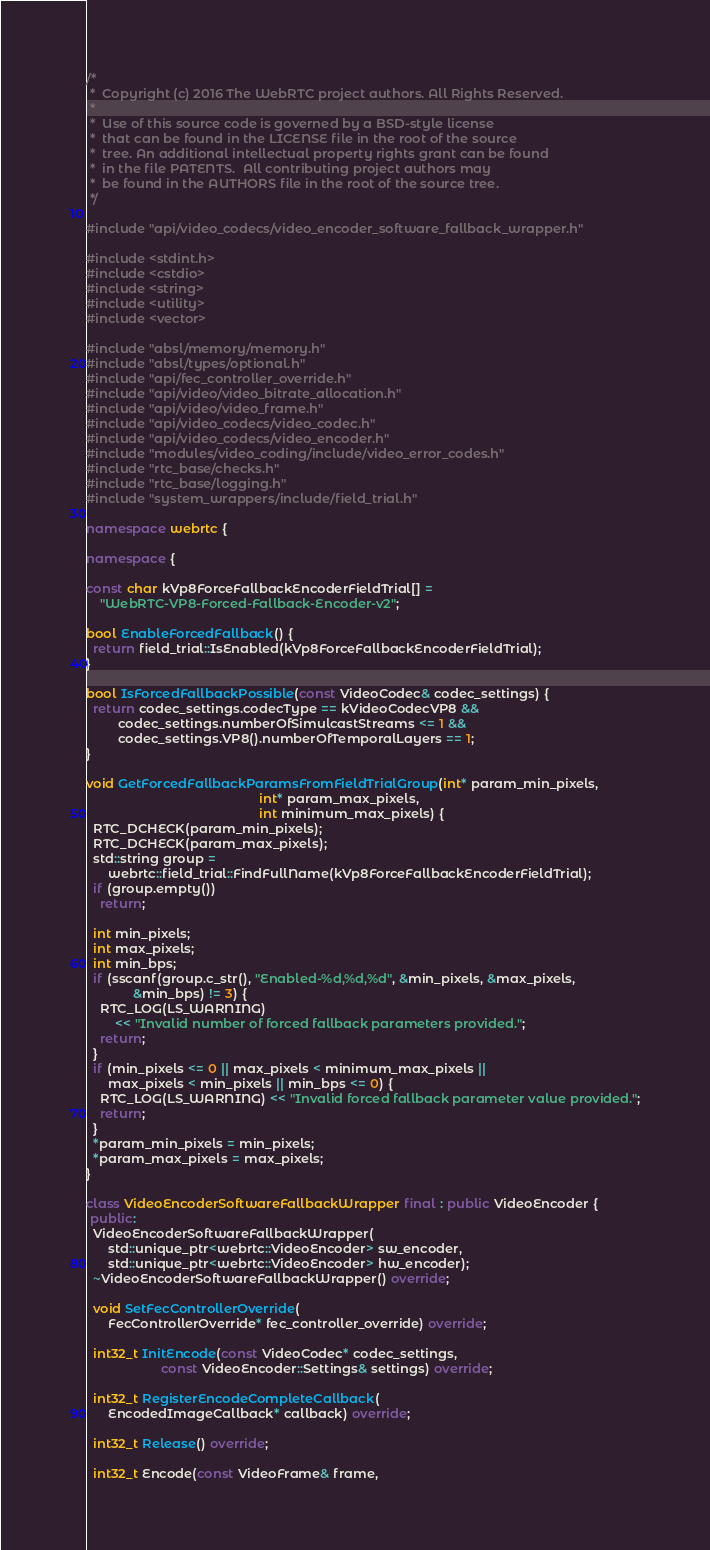<code> <loc_0><loc_0><loc_500><loc_500><_C++_>/*
 *  Copyright (c) 2016 The WebRTC project authors. All Rights Reserved.
 *
 *  Use of this source code is governed by a BSD-style license
 *  that can be found in the LICENSE file in the root of the source
 *  tree. An additional intellectual property rights grant can be found
 *  in the file PATENTS.  All contributing project authors may
 *  be found in the AUTHORS file in the root of the source tree.
 */

#include "api/video_codecs/video_encoder_software_fallback_wrapper.h"

#include <stdint.h>
#include <cstdio>
#include <string>
#include <utility>
#include <vector>

#include "absl/memory/memory.h"
#include "absl/types/optional.h"
#include "api/fec_controller_override.h"
#include "api/video/video_bitrate_allocation.h"
#include "api/video/video_frame.h"
#include "api/video_codecs/video_codec.h"
#include "api/video_codecs/video_encoder.h"
#include "modules/video_coding/include/video_error_codes.h"
#include "rtc_base/checks.h"
#include "rtc_base/logging.h"
#include "system_wrappers/include/field_trial.h"

namespace webrtc {

namespace {

const char kVp8ForceFallbackEncoderFieldTrial[] =
    "WebRTC-VP8-Forced-Fallback-Encoder-v2";

bool EnableForcedFallback() {
  return field_trial::IsEnabled(kVp8ForceFallbackEncoderFieldTrial);
}

bool IsForcedFallbackPossible(const VideoCodec& codec_settings) {
  return codec_settings.codecType == kVideoCodecVP8 &&
         codec_settings.numberOfSimulcastStreams <= 1 &&
         codec_settings.VP8().numberOfTemporalLayers == 1;
}

void GetForcedFallbackParamsFromFieldTrialGroup(int* param_min_pixels,
                                                int* param_max_pixels,
                                                int minimum_max_pixels) {
  RTC_DCHECK(param_min_pixels);
  RTC_DCHECK(param_max_pixels);
  std::string group =
      webrtc::field_trial::FindFullName(kVp8ForceFallbackEncoderFieldTrial);
  if (group.empty())
    return;

  int min_pixels;
  int max_pixels;
  int min_bps;
  if (sscanf(group.c_str(), "Enabled-%d,%d,%d", &min_pixels, &max_pixels,
             &min_bps) != 3) {
    RTC_LOG(LS_WARNING)
        << "Invalid number of forced fallback parameters provided.";
    return;
  }
  if (min_pixels <= 0 || max_pixels < minimum_max_pixels ||
      max_pixels < min_pixels || min_bps <= 0) {
    RTC_LOG(LS_WARNING) << "Invalid forced fallback parameter value provided.";
    return;
  }
  *param_min_pixels = min_pixels;
  *param_max_pixels = max_pixels;
}

class VideoEncoderSoftwareFallbackWrapper final : public VideoEncoder {
 public:
  VideoEncoderSoftwareFallbackWrapper(
      std::unique_ptr<webrtc::VideoEncoder> sw_encoder,
      std::unique_ptr<webrtc::VideoEncoder> hw_encoder);
  ~VideoEncoderSoftwareFallbackWrapper() override;

  void SetFecControllerOverride(
      FecControllerOverride* fec_controller_override) override;

  int32_t InitEncode(const VideoCodec* codec_settings,
                     const VideoEncoder::Settings& settings) override;

  int32_t RegisterEncodeCompleteCallback(
      EncodedImageCallback* callback) override;

  int32_t Release() override;

  int32_t Encode(const VideoFrame& frame,</code> 